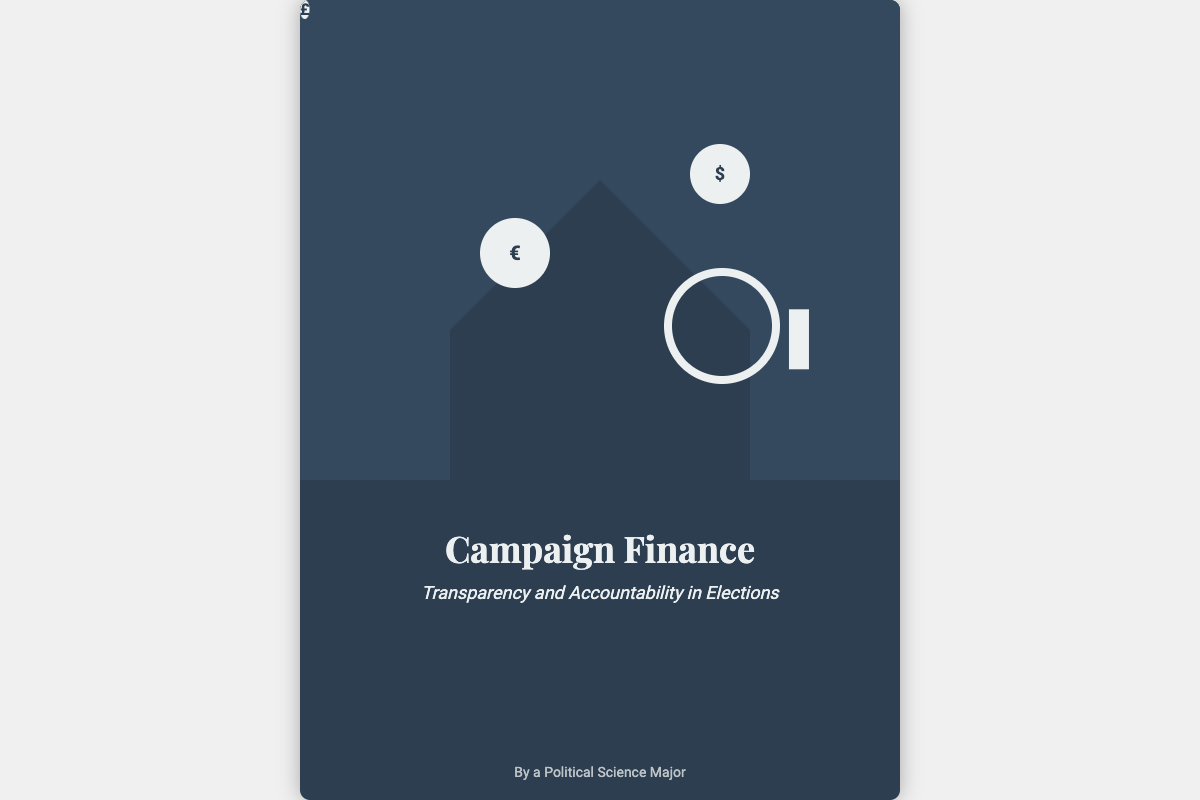What is the title of the book? The title of the book is displayed prominently on the cover as "Campaign Finance."
Answer: Campaign Finance What is the subtitle of the book? The subtitle is located beneath the title on the cover, stating the focus of the book.
Answer: Transparency and Accountability in Elections Who is the author of the book? The author is identified at the bottom of the cover, indicating the person behind the work.
Answer: By a Political Science Major What color is the background of the book cover? The overall background color of the book cover is dark, contributing to its professional appearance.
Answer: #2c3e50 What symbols are shown in the speech bubbles? The speech bubbles contain currency symbols which indicate themes related to financial transactions in campaigns.
Answer: $, €, £ What does the magnifying glass represent? The magnifying glass on the cover symbolizes scrutiny, suggesting a focus on transparency in campaign finance.
Answer: Scrutiny How many speech bubbles are present on the cover? The cover features a specific number of speech bubbles, which are used to enhance the visual theme of finance.
Answer: Three What theme does the silhouette of the politician convey? The silhouette is a visual representation that connects directly to the subject of political campaigning and finance.
Answer: Politics What feature gives the cover a shadow effect? The box shadow specified in the CSS adds depth to the book cover by creating a slight shadow around it.
Answer: Box shadow 